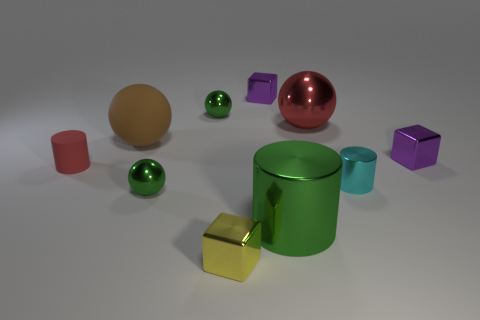Subtract all purple blocks. How many were subtracted if there are1purple blocks left? 1 Subtract all blocks. How many objects are left? 7 Add 9 red balls. How many red balls are left? 10 Add 3 tiny red matte balls. How many tiny red matte balls exist? 3 Subtract 1 yellow cubes. How many objects are left? 9 Subtract all brown objects. Subtract all green objects. How many objects are left? 6 